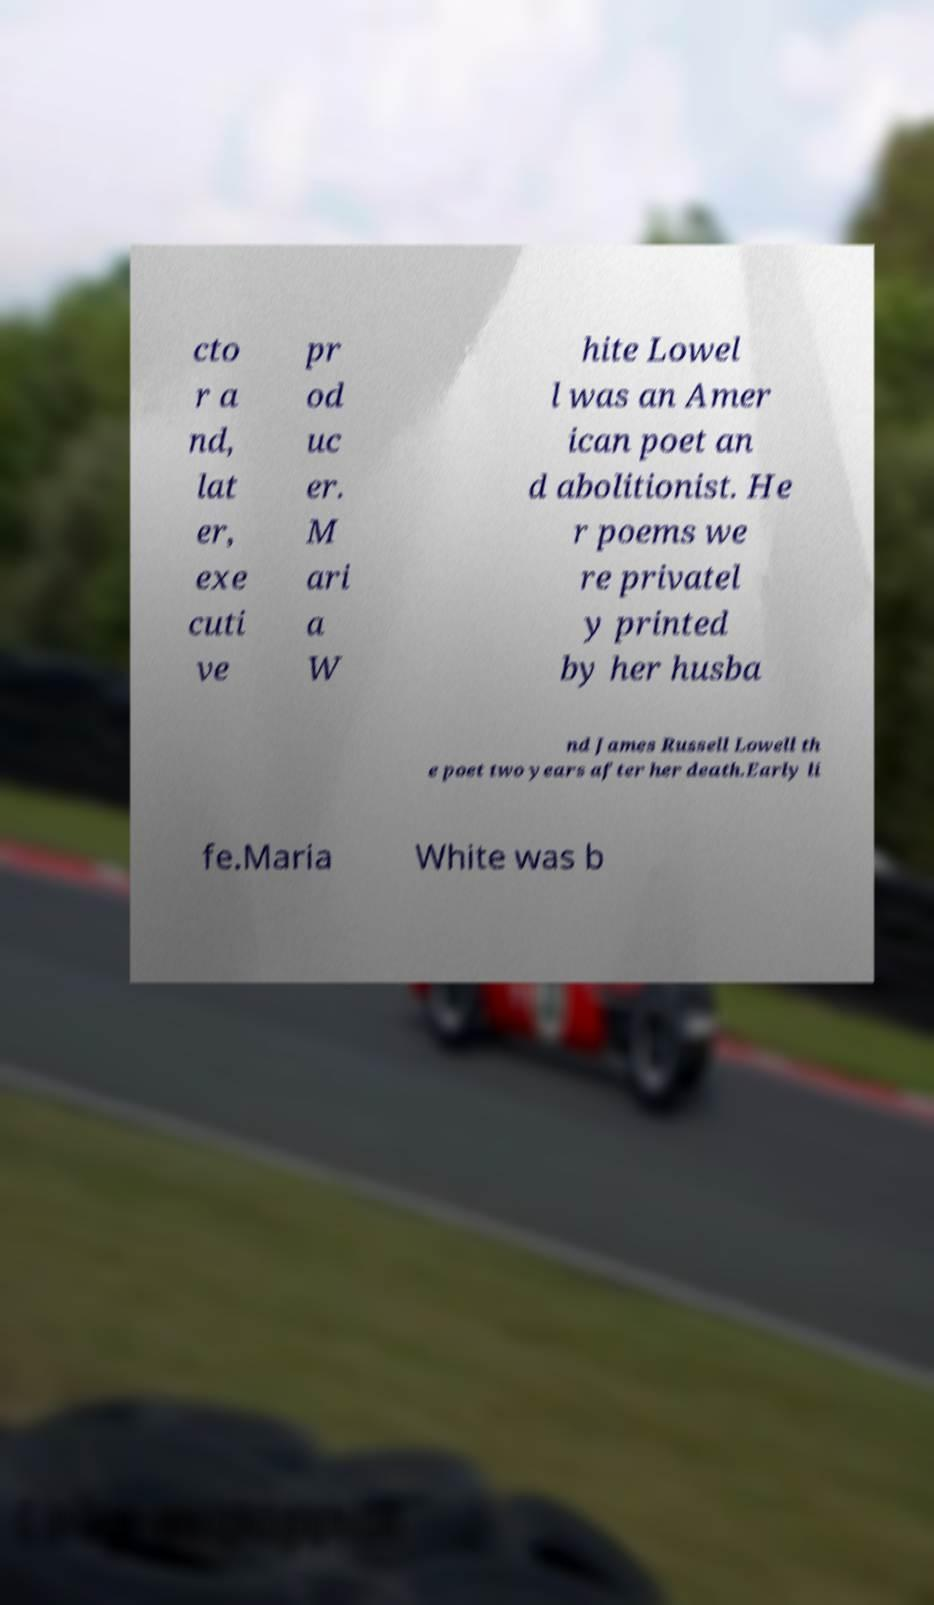Please identify and transcribe the text found in this image. cto r a nd, lat er, exe cuti ve pr od uc er. M ari a W hite Lowel l was an Amer ican poet an d abolitionist. He r poems we re privatel y printed by her husba nd James Russell Lowell th e poet two years after her death.Early li fe.Maria White was b 